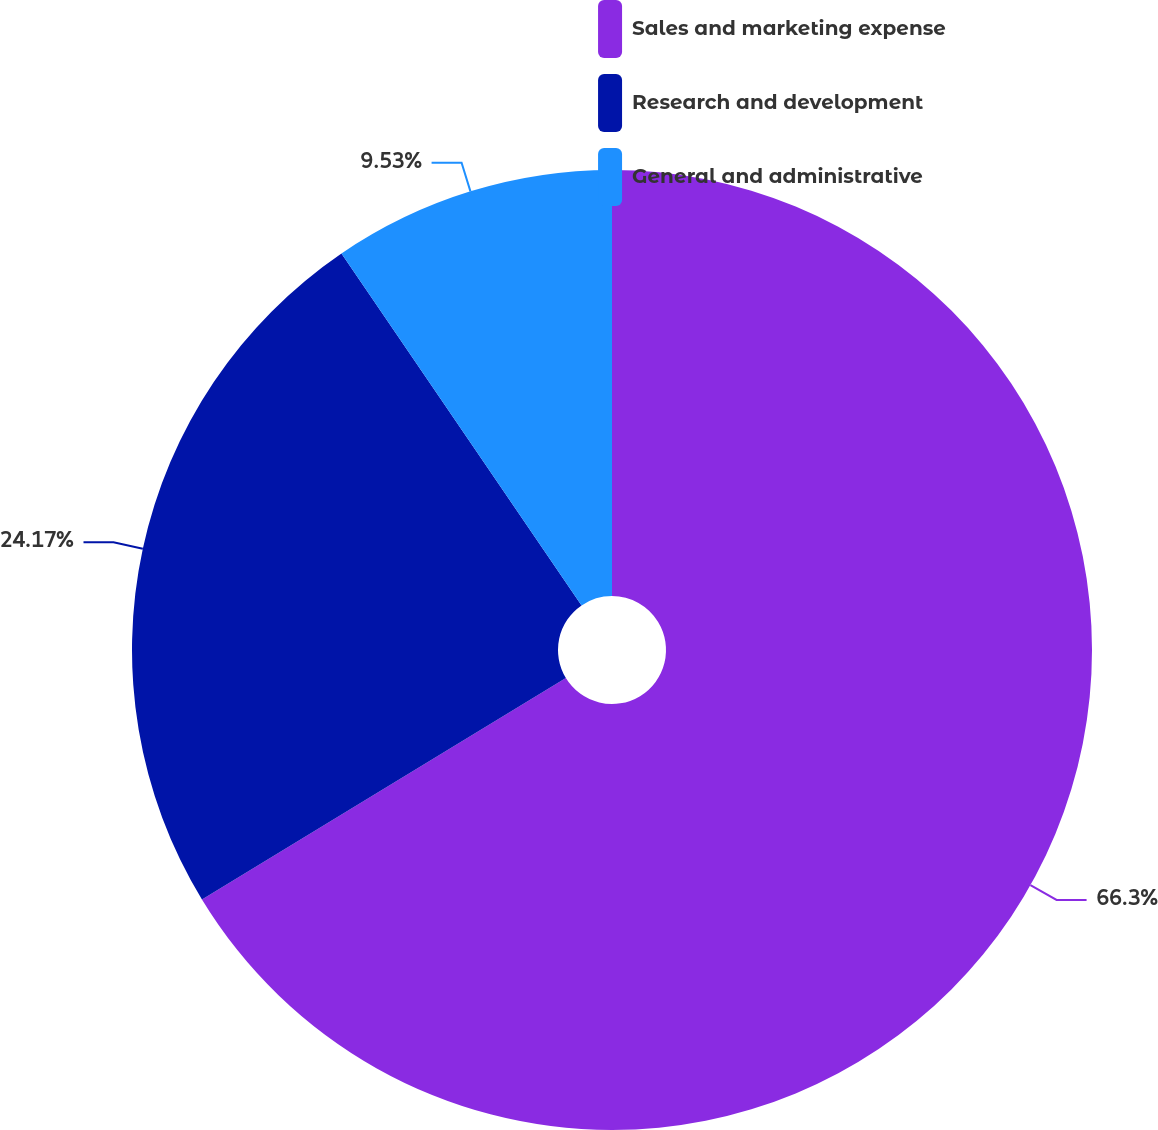Convert chart. <chart><loc_0><loc_0><loc_500><loc_500><pie_chart><fcel>Sales and marketing expense<fcel>Research and development<fcel>General and administrative<nl><fcel>66.3%<fcel>24.17%<fcel>9.53%<nl></chart> 